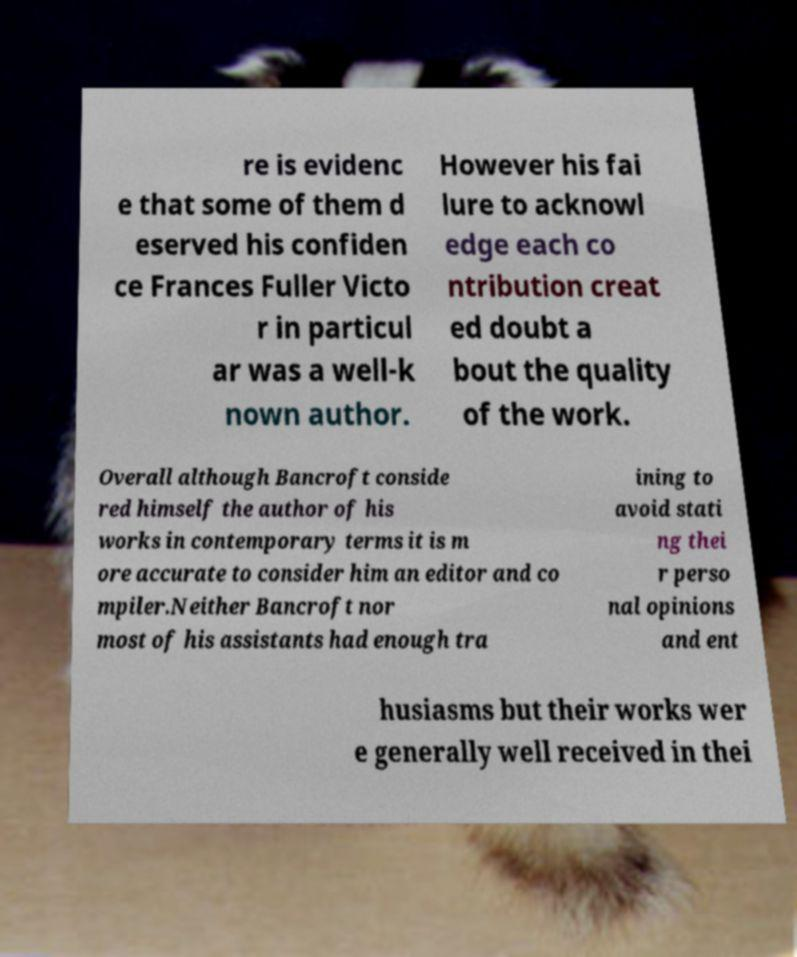For documentation purposes, I need the text within this image transcribed. Could you provide that? re is evidenc e that some of them d eserved his confiden ce Frances Fuller Victo r in particul ar was a well-k nown author. However his fai lure to acknowl edge each co ntribution creat ed doubt a bout the quality of the work. Overall although Bancroft conside red himself the author of his works in contemporary terms it is m ore accurate to consider him an editor and co mpiler.Neither Bancroft nor most of his assistants had enough tra ining to avoid stati ng thei r perso nal opinions and ent husiasms but their works wer e generally well received in thei 